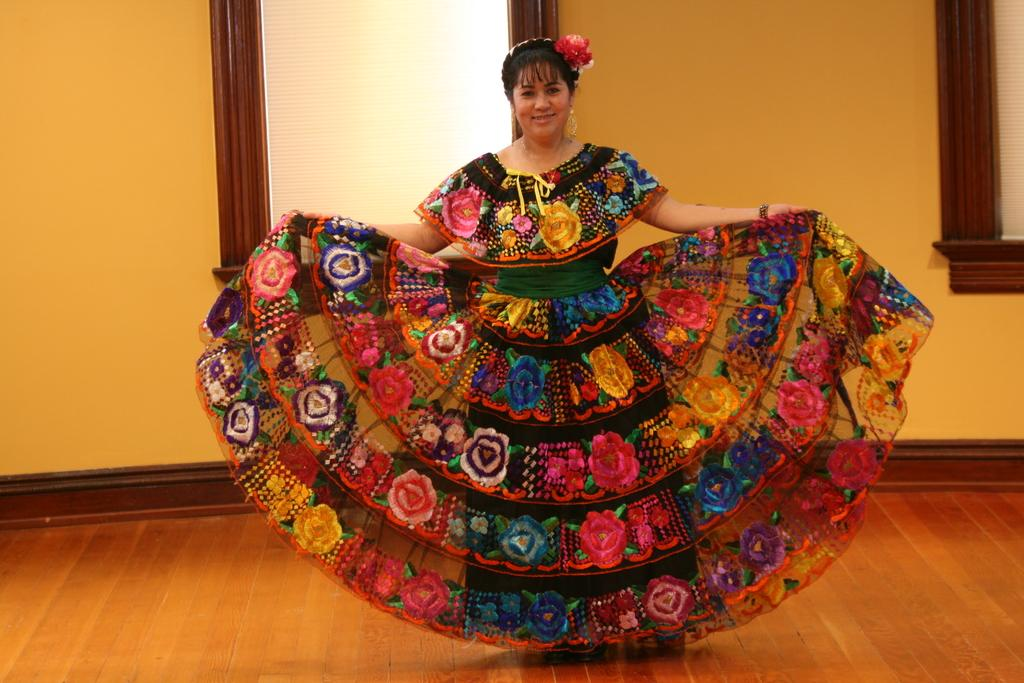Who is the main subject in the image? There is a woman in the image. What is the woman wearing in the image? The woman is wearing a frock, earrings, and a hair band. What can be seen behind the woman in the image? There are windows visible behind the woman. What type of trade is the woman involved in, as seen in the image? There is no indication of any trade or profession in the image; it simply shows a woman wearing a frock, earrings, and a hair band. How many sons does the woman have, as seen in the image? There is no information about the woman's family or children in the image. 